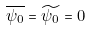<formula> <loc_0><loc_0><loc_500><loc_500>\overline { \psi _ { 0 } } = \widetilde { \psi _ { 0 } } = 0</formula> 